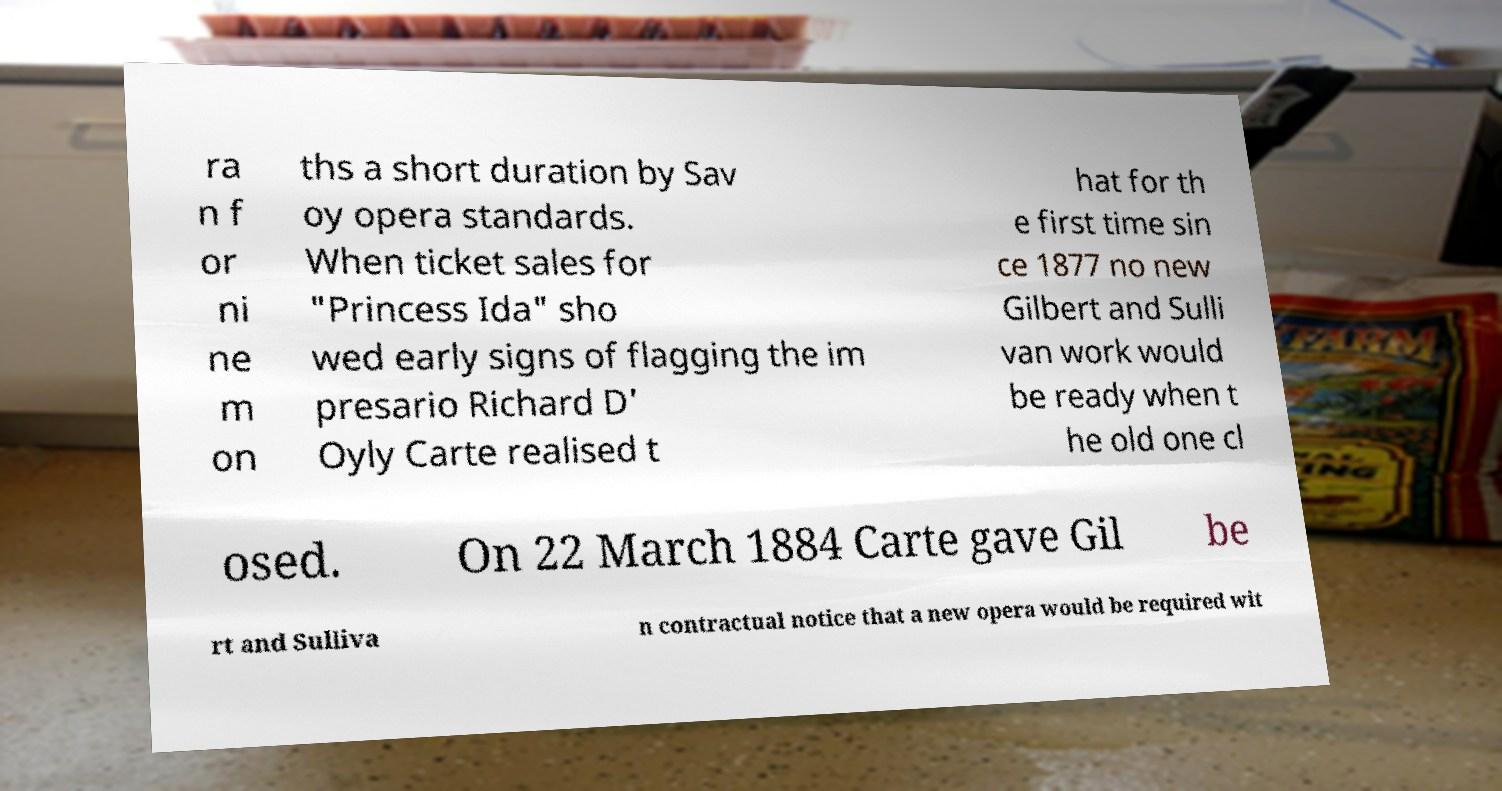Please identify and transcribe the text found in this image. ra n f or ni ne m on ths a short duration by Sav oy opera standards. When ticket sales for "Princess Ida" sho wed early signs of flagging the im presario Richard D' Oyly Carte realised t hat for th e first time sin ce 1877 no new Gilbert and Sulli van work would be ready when t he old one cl osed. On 22 March 1884 Carte gave Gil be rt and Sulliva n contractual notice that a new opera would be required wit 